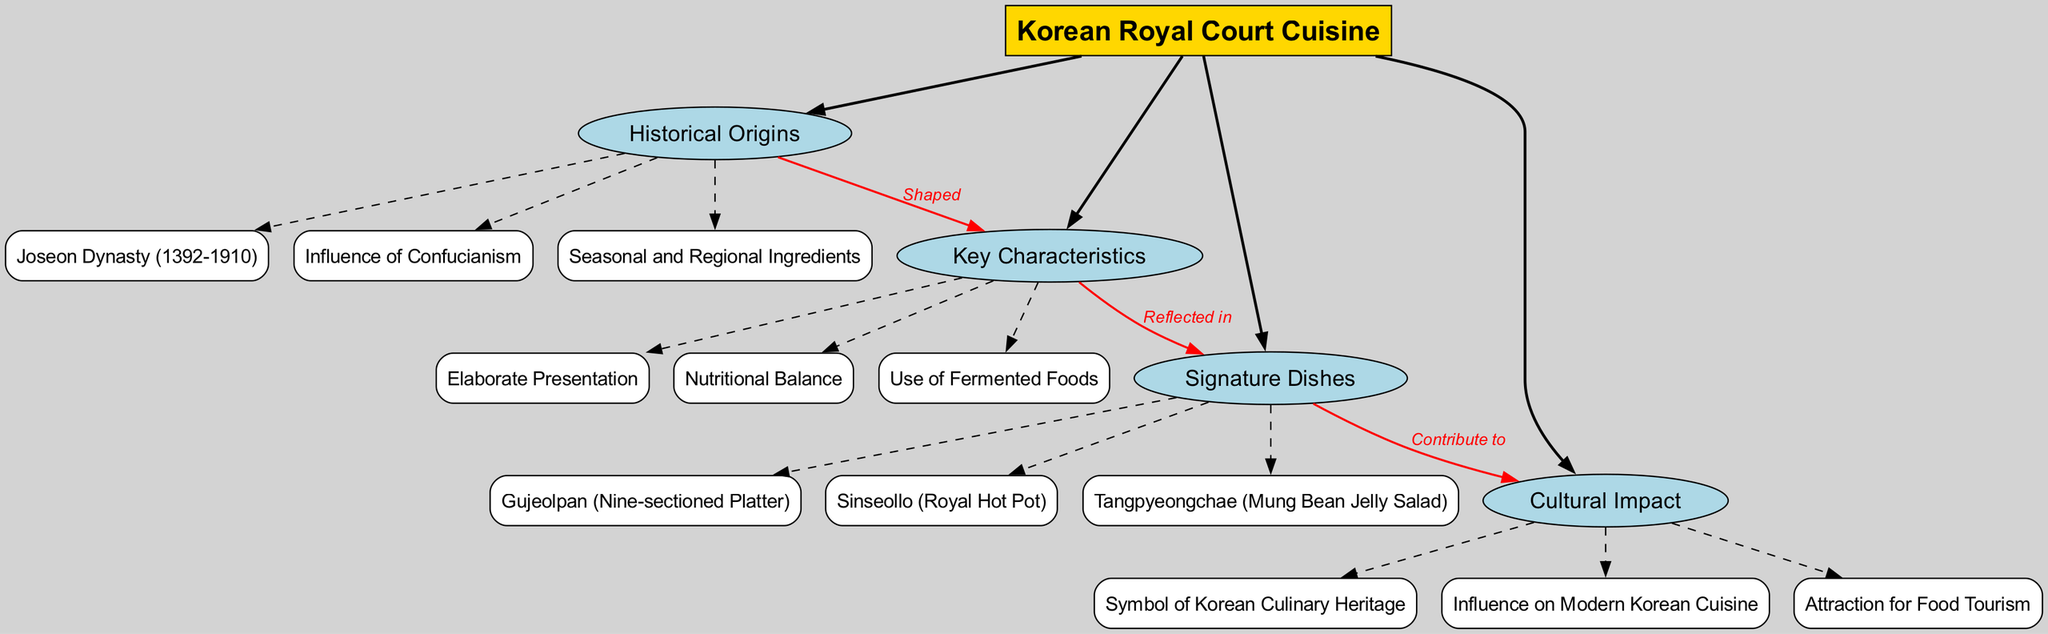What are the three main branches of Korean royal court cuisine? The diagram lists four main branches under the central concept of Korean Royal Court Cuisine: Historical Origins, Key Characteristics, Signature Dishes, and Cultural Impact. Therefore, there are three main branches.
Answer: Historical Origins, Key Characteristics, Signature Dishes, Cultural Impact How many sub-branches does the "Key Characteristics" branch have? Under the Key Characteristics branch, there are three sub-branches: Elaborate Presentation, Nutritional Balance, and Use of Fermented Foods. Thus, it has three sub-branches.
Answer: 3 Which dish is categorized under "Signature Dishes"? The Signature Dishes branch has three specific dishes listed under it: Gujeolpan, Sinseollo, and Tangpyeongchae. Therefore, any of these dishes is an answer to the question.
Answer: Gujeolpan What relationship does "Historical Origins" have with "Key Characteristics"? The diagram shows that Historical Origins shaped Key Characteristics, indicating a direct influence between these two branches.
Answer: Shaped How does "Signature Dishes" contribute to "Cultural Impact"? According to the connections in the diagram, Signature Dishes contribute to Cultural Impact, indicating that the signature dishes have a role in affecting cultural significance.
Answer: Contribute to Name one influence on Korean Royal Court Cuisine from the "Cultural Impact" branch. The diagram shows three influences listed under Cultural Impact: Symbol of Korean Culinary Heritage, Influence on Modern Korean Cuisine, and Attraction for Food Tourism. Any one of these would be a valid answer.
Answer: Symbol of Korean Culinary Heritage How many connections are shown between branches in the diagram? The diagram outlines three distinct connections between branches: Historical Origins to Key Characteristics, Key Characteristics to Signature Dishes, and Signature Dishes to Cultural Impact, totaling three connections.
Answer: 3 Which historical period is indicated as the origin of Korean royal court cuisine? The Historical Origins branch states that the Joseon Dynasty (1392-1910) is a main reference point for the origins of Korean royal court cuisine, thus directly answering the question.
Answer: Joseon Dynasty (1392-1910) What does "Use of Fermented Foods" reflect in the context of the diagram? The Key Characteristics include "Use of Fermented Foods," which reflects in the way Signature Dishes are prepared and presented, linking the characteristic directly to the dishes.
Answer: Reflects in Signature Dishes 